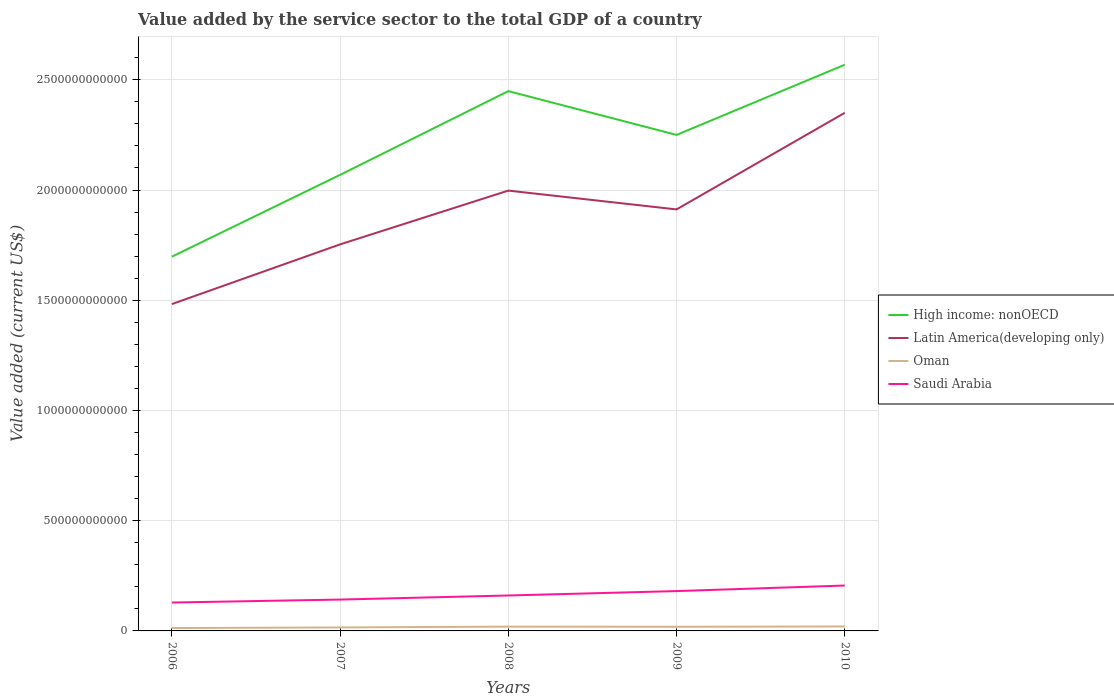How many different coloured lines are there?
Give a very brief answer. 4. Is the number of lines equal to the number of legend labels?
Ensure brevity in your answer.  Yes. Across all years, what is the maximum value added by the service sector to the total GDP in Saudi Arabia?
Offer a terse response. 1.29e+11. What is the total value added by the service sector to the total GDP in Oman in the graph?
Offer a very short reply. -2.80e+09. What is the difference between the highest and the second highest value added by the service sector to the total GDP in Latin America(developing only)?
Give a very brief answer. 8.68e+11. How many years are there in the graph?
Keep it short and to the point. 5. What is the difference between two consecutive major ticks on the Y-axis?
Keep it short and to the point. 5.00e+11. Does the graph contain any zero values?
Your response must be concise. No. Where does the legend appear in the graph?
Offer a very short reply. Center right. How many legend labels are there?
Provide a short and direct response. 4. How are the legend labels stacked?
Offer a very short reply. Vertical. What is the title of the graph?
Keep it short and to the point. Value added by the service sector to the total GDP of a country. Does "Russian Federation" appear as one of the legend labels in the graph?
Your response must be concise. No. What is the label or title of the Y-axis?
Offer a very short reply. Value added (current US$). What is the Value added (current US$) in High income: nonOECD in 2006?
Provide a short and direct response. 1.70e+12. What is the Value added (current US$) of Latin America(developing only) in 2006?
Offer a very short reply. 1.48e+12. What is the Value added (current US$) in Oman in 2006?
Your answer should be very brief. 1.30e+1. What is the Value added (current US$) in Saudi Arabia in 2006?
Ensure brevity in your answer.  1.29e+11. What is the Value added (current US$) in High income: nonOECD in 2007?
Make the answer very short. 2.07e+12. What is the Value added (current US$) of Latin America(developing only) in 2007?
Make the answer very short. 1.75e+12. What is the Value added (current US$) of Oman in 2007?
Keep it short and to the point. 1.58e+1. What is the Value added (current US$) of Saudi Arabia in 2007?
Your answer should be very brief. 1.42e+11. What is the Value added (current US$) in High income: nonOECD in 2008?
Your response must be concise. 2.45e+12. What is the Value added (current US$) of Latin America(developing only) in 2008?
Your answer should be compact. 2.00e+12. What is the Value added (current US$) in Oman in 2008?
Your answer should be very brief. 1.95e+1. What is the Value added (current US$) in Saudi Arabia in 2008?
Offer a terse response. 1.61e+11. What is the Value added (current US$) of High income: nonOECD in 2009?
Offer a very short reply. 2.25e+12. What is the Value added (current US$) in Latin America(developing only) in 2009?
Offer a very short reply. 1.91e+12. What is the Value added (current US$) in Oman in 2009?
Ensure brevity in your answer.  1.88e+1. What is the Value added (current US$) of Saudi Arabia in 2009?
Provide a succinct answer. 1.81e+11. What is the Value added (current US$) of High income: nonOECD in 2010?
Provide a short and direct response. 2.57e+12. What is the Value added (current US$) in Latin America(developing only) in 2010?
Provide a succinct answer. 2.35e+12. What is the Value added (current US$) of Oman in 2010?
Provide a succinct answer. 2.02e+1. What is the Value added (current US$) in Saudi Arabia in 2010?
Keep it short and to the point. 2.06e+11. Across all years, what is the maximum Value added (current US$) of High income: nonOECD?
Your answer should be compact. 2.57e+12. Across all years, what is the maximum Value added (current US$) of Latin America(developing only)?
Offer a very short reply. 2.35e+12. Across all years, what is the maximum Value added (current US$) in Oman?
Keep it short and to the point. 2.02e+1. Across all years, what is the maximum Value added (current US$) of Saudi Arabia?
Make the answer very short. 2.06e+11. Across all years, what is the minimum Value added (current US$) of High income: nonOECD?
Provide a short and direct response. 1.70e+12. Across all years, what is the minimum Value added (current US$) in Latin America(developing only)?
Provide a short and direct response. 1.48e+12. Across all years, what is the minimum Value added (current US$) of Oman?
Offer a terse response. 1.30e+1. Across all years, what is the minimum Value added (current US$) of Saudi Arabia?
Ensure brevity in your answer.  1.29e+11. What is the total Value added (current US$) in High income: nonOECD in the graph?
Provide a short and direct response. 1.10e+13. What is the total Value added (current US$) of Latin America(developing only) in the graph?
Your answer should be compact. 9.50e+12. What is the total Value added (current US$) in Oman in the graph?
Provide a short and direct response. 8.73e+1. What is the total Value added (current US$) of Saudi Arabia in the graph?
Give a very brief answer. 8.18e+11. What is the difference between the Value added (current US$) in High income: nonOECD in 2006 and that in 2007?
Provide a succinct answer. -3.71e+11. What is the difference between the Value added (current US$) of Latin America(developing only) in 2006 and that in 2007?
Keep it short and to the point. -2.71e+11. What is the difference between the Value added (current US$) in Oman in 2006 and that in 2007?
Your response must be concise. -2.80e+09. What is the difference between the Value added (current US$) of Saudi Arabia in 2006 and that in 2007?
Offer a terse response. -1.34e+1. What is the difference between the Value added (current US$) in High income: nonOECD in 2006 and that in 2008?
Your answer should be compact. -7.51e+11. What is the difference between the Value added (current US$) in Latin America(developing only) in 2006 and that in 2008?
Make the answer very short. -5.15e+11. What is the difference between the Value added (current US$) of Oman in 2006 and that in 2008?
Offer a very short reply. -6.47e+09. What is the difference between the Value added (current US$) in Saudi Arabia in 2006 and that in 2008?
Your answer should be very brief. -3.20e+1. What is the difference between the Value added (current US$) of High income: nonOECD in 2006 and that in 2009?
Make the answer very short. -5.52e+11. What is the difference between the Value added (current US$) in Latin America(developing only) in 2006 and that in 2009?
Provide a short and direct response. -4.29e+11. What is the difference between the Value added (current US$) in Oman in 2006 and that in 2009?
Your response must be concise. -5.85e+09. What is the difference between the Value added (current US$) of Saudi Arabia in 2006 and that in 2009?
Your answer should be very brief. -5.20e+1. What is the difference between the Value added (current US$) in High income: nonOECD in 2006 and that in 2010?
Keep it short and to the point. -8.71e+11. What is the difference between the Value added (current US$) in Latin America(developing only) in 2006 and that in 2010?
Offer a terse response. -8.68e+11. What is the difference between the Value added (current US$) in Oman in 2006 and that in 2010?
Your answer should be compact. -7.26e+09. What is the difference between the Value added (current US$) of Saudi Arabia in 2006 and that in 2010?
Give a very brief answer. -7.71e+1. What is the difference between the Value added (current US$) of High income: nonOECD in 2007 and that in 2008?
Offer a very short reply. -3.80e+11. What is the difference between the Value added (current US$) in Latin America(developing only) in 2007 and that in 2008?
Provide a succinct answer. -2.44e+11. What is the difference between the Value added (current US$) of Oman in 2007 and that in 2008?
Keep it short and to the point. -3.67e+09. What is the difference between the Value added (current US$) in Saudi Arabia in 2007 and that in 2008?
Make the answer very short. -1.85e+1. What is the difference between the Value added (current US$) in High income: nonOECD in 2007 and that in 2009?
Offer a very short reply. -1.81e+11. What is the difference between the Value added (current US$) of Latin America(developing only) in 2007 and that in 2009?
Provide a succinct answer. -1.59e+11. What is the difference between the Value added (current US$) of Oman in 2007 and that in 2009?
Your answer should be very brief. -3.05e+09. What is the difference between the Value added (current US$) of Saudi Arabia in 2007 and that in 2009?
Your response must be concise. -3.85e+1. What is the difference between the Value added (current US$) of High income: nonOECD in 2007 and that in 2010?
Keep it short and to the point. -4.99e+11. What is the difference between the Value added (current US$) of Latin America(developing only) in 2007 and that in 2010?
Give a very brief answer. -5.97e+11. What is the difference between the Value added (current US$) of Oman in 2007 and that in 2010?
Offer a terse response. -4.47e+09. What is the difference between the Value added (current US$) in Saudi Arabia in 2007 and that in 2010?
Your answer should be compact. -6.36e+1. What is the difference between the Value added (current US$) in High income: nonOECD in 2008 and that in 2009?
Offer a terse response. 1.99e+11. What is the difference between the Value added (current US$) of Latin America(developing only) in 2008 and that in 2009?
Offer a terse response. 8.53e+1. What is the difference between the Value added (current US$) of Oman in 2008 and that in 2009?
Keep it short and to the point. 6.25e+08. What is the difference between the Value added (current US$) of Saudi Arabia in 2008 and that in 2009?
Your answer should be very brief. -2.00e+1. What is the difference between the Value added (current US$) of High income: nonOECD in 2008 and that in 2010?
Ensure brevity in your answer.  -1.20e+11. What is the difference between the Value added (current US$) in Latin America(developing only) in 2008 and that in 2010?
Provide a short and direct response. -3.53e+11. What is the difference between the Value added (current US$) in Oman in 2008 and that in 2010?
Offer a very short reply. -7.91e+08. What is the difference between the Value added (current US$) of Saudi Arabia in 2008 and that in 2010?
Make the answer very short. -4.51e+1. What is the difference between the Value added (current US$) in High income: nonOECD in 2009 and that in 2010?
Give a very brief answer. -3.18e+11. What is the difference between the Value added (current US$) in Latin America(developing only) in 2009 and that in 2010?
Keep it short and to the point. -4.38e+11. What is the difference between the Value added (current US$) of Oman in 2009 and that in 2010?
Provide a short and direct response. -1.42e+09. What is the difference between the Value added (current US$) of Saudi Arabia in 2009 and that in 2010?
Make the answer very short. -2.51e+1. What is the difference between the Value added (current US$) of High income: nonOECD in 2006 and the Value added (current US$) of Latin America(developing only) in 2007?
Your response must be concise. -5.58e+1. What is the difference between the Value added (current US$) in High income: nonOECD in 2006 and the Value added (current US$) in Oman in 2007?
Give a very brief answer. 1.68e+12. What is the difference between the Value added (current US$) of High income: nonOECD in 2006 and the Value added (current US$) of Saudi Arabia in 2007?
Your response must be concise. 1.56e+12. What is the difference between the Value added (current US$) in Latin America(developing only) in 2006 and the Value added (current US$) in Oman in 2007?
Your answer should be very brief. 1.47e+12. What is the difference between the Value added (current US$) of Latin America(developing only) in 2006 and the Value added (current US$) of Saudi Arabia in 2007?
Keep it short and to the point. 1.34e+12. What is the difference between the Value added (current US$) of Oman in 2006 and the Value added (current US$) of Saudi Arabia in 2007?
Make the answer very short. -1.29e+11. What is the difference between the Value added (current US$) in High income: nonOECD in 2006 and the Value added (current US$) in Latin America(developing only) in 2008?
Make the answer very short. -3.00e+11. What is the difference between the Value added (current US$) of High income: nonOECD in 2006 and the Value added (current US$) of Oman in 2008?
Provide a succinct answer. 1.68e+12. What is the difference between the Value added (current US$) of High income: nonOECD in 2006 and the Value added (current US$) of Saudi Arabia in 2008?
Ensure brevity in your answer.  1.54e+12. What is the difference between the Value added (current US$) of Latin America(developing only) in 2006 and the Value added (current US$) of Oman in 2008?
Offer a terse response. 1.46e+12. What is the difference between the Value added (current US$) of Latin America(developing only) in 2006 and the Value added (current US$) of Saudi Arabia in 2008?
Your answer should be compact. 1.32e+12. What is the difference between the Value added (current US$) of Oman in 2006 and the Value added (current US$) of Saudi Arabia in 2008?
Your answer should be very brief. -1.48e+11. What is the difference between the Value added (current US$) of High income: nonOECD in 2006 and the Value added (current US$) of Latin America(developing only) in 2009?
Provide a succinct answer. -2.14e+11. What is the difference between the Value added (current US$) in High income: nonOECD in 2006 and the Value added (current US$) in Oman in 2009?
Offer a terse response. 1.68e+12. What is the difference between the Value added (current US$) of High income: nonOECD in 2006 and the Value added (current US$) of Saudi Arabia in 2009?
Keep it short and to the point. 1.52e+12. What is the difference between the Value added (current US$) in Latin America(developing only) in 2006 and the Value added (current US$) in Oman in 2009?
Offer a very short reply. 1.46e+12. What is the difference between the Value added (current US$) in Latin America(developing only) in 2006 and the Value added (current US$) in Saudi Arabia in 2009?
Your answer should be compact. 1.30e+12. What is the difference between the Value added (current US$) in Oman in 2006 and the Value added (current US$) in Saudi Arabia in 2009?
Your answer should be compact. -1.68e+11. What is the difference between the Value added (current US$) of High income: nonOECD in 2006 and the Value added (current US$) of Latin America(developing only) in 2010?
Provide a succinct answer. -6.53e+11. What is the difference between the Value added (current US$) of High income: nonOECD in 2006 and the Value added (current US$) of Oman in 2010?
Give a very brief answer. 1.68e+12. What is the difference between the Value added (current US$) of High income: nonOECD in 2006 and the Value added (current US$) of Saudi Arabia in 2010?
Provide a succinct answer. 1.49e+12. What is the difference between the Value added (current US$) of Latin America(developing only) in 2006 and the Value added (current US$) of Oman in 2010?
Keep it short and to the point. 1.46e+12. What is the difference between the Value added (current US$) in Latin America(developing only) in 2006 and the Value added (current US$) in Saudi Arabia in 2010?
Offer a very short reply. 1.28e+12. What is the difference between the Value added (current US$) of Oman in 2006 and the Value added (current US$) of Saudi Arabia in 2010?
Give a very brief answer. -1.93e+11. What is the difference between the Value added (current US$) of High income: nonOECD in 2007 and the Value added (current US$) of Latin America(developing only) in 2008?
Keep it short and to the point. 7.14e+1. What is the difference between the Value added (current US$) of High income: nonOECD in 2007 and the Value added (current US$) of Oman in 2008?
Keep it short and to the point. 2.05e+12. What is the difference between the Value added (current US$) in High income: nonOECD in 2007 and the Value added (current US$) in Saudi Arabia in 2008?
Provide a succinct answer. 1.91e+12. What is the difference between the Value added (current US$) of Latin America(developing only) in 2007 and the Value added (current US$) of Oman in 2008?
Your answer should be very brief. 1.73e+12. What is the difference between the Value added (current US$) in Latin America(developing only) in 2007 and the Value added (current US$) in Saudi Arabia in 2008?
Offer a very short reply. 1.59e+12. What is the difference between the Value added (current US$) in Oman in 2007 and the Value added (current US$) in Saudi Arabia in 2008?
Ensure brevity in your answer.  -1.45e+11. What is the difference between the Value added (current US$) in High income: nonOECD in 2007 and the Value added (current US$) in Latin America(developing only) in 2009?
Give a very brief answer. 1.57e+11. What is the difference between the Value added (current US$) in High income: nonOECD in 2007 and the Value added (current US$) in Oman in 2009?
Offer a very short reply. 2.05e+12. What is the difference between the Value added (current US$) in High income: nonOECD in 2007 and the Value added (current US$) in Saudi Arabia in 2009?
Give a very brief answer. 1.89e+12. What is the difference between the Value added (current US$) in Latin America(developing only) in 2007 and the Value added (current US$) in Oman in 2009?
Give a very brief answer. 1.73e+12. What is the difference between the Value added (current US$) in Latin America(developing only) in 2007 and the Value added (current US$) in Saudi Arabia in 2009?
Your answer should be compact. 1.57e+12. What is the difference between the Value added (current US$) in Oman in 2007 and the Value added (current US$) in Saudi Arabia in 2009?
Your response must be concise. -1.65e+11. What is the difference between the Value added (current US$) in High income: nonOECD in 2007 and the Value added (current US$) in Latin America(developing only) in 2010?
Provide a succinct answer. -2.81e+11. What is the difference between the Value added (current US$) in High income: nonOECD in 2007 and the Value added (current US$) in Oman in 2010?
Ensure brevity in your answer.  2.05e+12. What is the difference between the Value added (current US$) in High income: nonOECD in 2007 and the Value added (current US$) in Saudi Arabia in 2010?
Make the answer very short. 1.86e+12. What is the difference between the Value added (current US$) of Latin America(developing only) in 2007 and the Value added (current US$) of Oman in 2010?
Give a very brief answer. 1.73e+12. What is the difference between the Value added (current US$) of Latin America(developing only) in 2007 and the Value added (current US$) of Saudi Arabia in 2010?
Your answer should be very brief. 1.55e+12. What is the difference between the Value added (current US$) in Oman in 2007 and the Value added (current US$) in Saudi Arabia in 2010?
Offer a very short reply. -1.90e+11. What is the difference between the Value added (current US$) in High income: nonOECD in 2008 and the Value added (current US$) in Latin America(developing only) in 2009?
Keep it short and to the point. 5.37e+11. What is the difference between the Value added (current US$) of High income: nonOECD in 2008 and the Value added (current US$) of Oman in 2009?
Provide a succinct answer. 2.43e+12. What is the difference between the Value added (current US$) of High income: nonOECD in 2008 and the Value added (current US$) of Saudi Arabia in 2009?
Provide a succinct answer. 2.27e+12. What is the difference between the Value added (current US$) of Latin America(developing only) in 2008 and the Value added (current US$) of Oman in 2009?
Ensure brevity in your answer.  1.98e+12. What is the difference between the Value added (current US$) of Latin America(developing only) in 2008 and the Value added (current US$) of Saudi Arabia in 2009?
Keep it short and to the point. 1.82e+12. What is the difference between the Value added (current US$) of Oman in 2008 and the Value added (current US$) of Saudi Arabia in 2009?
Make the answer very short. -1.61e+11. What is the difference between the Value added (current US$) in High income: nonOECD in 2008 and the Value added (current US$) in Latin America(developing only) in 2010?
Give a very brief answer. 9.83e+1. What is the difference between the Value added (current US$) of High income: nonOECD in 2008 and the Value added (current US$) of Oman in 2010?
Provide a succinct answer. 2.43e+12. What is the difference between the Value added (current US$) of High income: nonOECD in 2008 and the Value added (current US$) of Saudi Arabia in 2010?
Provide a short and direct response. 2.24e+12. What is the difference between the Value added (current US$) of Latin America(developing only) in 2008 and the Value added (current US$) of Oman in 2010?
Give a very brief answer. 1.98e+12. What is the difference between the Value added (current US$) in Latin America(developing only) in 2008 and the Value added (current US$) in Saudi Arabia in 2010?
Ensure brevity in your answer.  1.79e+12. What is the difference between the Value added (current US$) in Oman in 2008 and the Value added (current US$) in Saudi Arabia in 2010?
Offer a terse response. -1.86e+11. What is the difference between the Value added (current US$) in High income: nonOECD in 2009 and the Value added (current US$) in Latin America(developing only) in 2010?
Ensure brevity in your answer.  -1.00e+11. What is the difference between the Value added (current US$) of High income: nonOECD in 2009 and the Value added (current US$) of Oman in 2010?
Provide a short and direct response. 2.23e+12. What is the difference between the Value added (current US$) of High income: nonOECD in 2009 and the Value added (current US$) of Saudi Arabia in 2010?
Provide a succinct answer. 2.04e+12. What is the difference between the Value added (current US$) in Latin America(developing only) in 2009 and the Value added (current US$) in Oman in 2010?
Offer a terse response. 1.89e+12. What is the difference between the Value added (current US$) of Latin America(developing only) in 2009 and the Value added (current US$) of Saudi Arabia in 2010?
Your answer should be very brief. 1.71e+12. What is the difference between the Value added (current US$) in Oman in 2009 and the Value added (current US$) in Saudi Arabia in 2010?
Make the answer very short. -1.87e+11. What is the average Value added (current US$) in High income: nonOECD per year?
Make the answer very short. 2.21e+12. What is the average Value added (current US$) in Latin America(developing only) per year?
Ensure brevity in your answer.  1.90e+12. What is the average Value added (current US$) of Oman per year?
Your answer should be compact. 1.75e+1. What is the average Value added (current US$) of Saudi Arabia per year?
Give a very brief answer. 1.64e+11. In the year 2006, what is the difference between the Value added (current US$) in High income: nonOECD and Value added (current US$) in Latin America(developing only)?
Keep it short and to the point. 2.15e+11. In the year 2006, what is the difference between the Value added (current US$) in High income: nonOECD and Value added (current US$) in Oman?
Offer a terse response. 1.68e+12. In the year 2006, what is the difference between the Value added (current US$) in High income: nonOECD and Value added (current US$) in Saudi Arabia?
Make the answer very short. 1.57e+12. In the year 2006, what is the difference between the Value added (current US$) in Latin America(developing only) and Value added (current US$) in Oman?
Keep it short and to the point. 1.47e+12. In the year 2006, what is the difference between the Value added (current US$) in Latin America(developing only) and Value added (current US$) in Saudi Arabia?
Offer a very short reply. 1.35e+12. In the year 2006, what is the difference between the Value added (current US$) of Oman and Value added (current US$) of Saudi Arabia?
Provide a succinct answer. -1.16e+11. In the year 2007, what is the difference between the Value added (current US$) in High income: nonOECD and Value added (current US$) in Latin America(developing only)?
Your answer should be compact. 3.15e+11. In the year 2007, what is the difference between the Value added (current US$) in High income: nonOECD and Value added (current US$) in Oman?
Make the answer very short. 2.05e+12. In the year 2007, what is the difference between the Value added (current US$) of High income: nonOECD and Value added (current US$) of Saudi Arabia?
Give a very brief answer. 1.93e+12. In the year 2007, what is the difference between the Value added (current US$) in Latin America(developing only) and Value added (current US$) in Oman?
Your response must be concise. 1.74e+12. In the year 2007, what is the difference between the Value added (current US$) in Latin America(developing only) and Value added (current US$) in Saudi Arabia?
Offer a very short reply. 1.61e+12. In the year 2007, what is the difference between the Value added (current US$) of Oman and Value added (current US$) of Saudi Arabia?
Provide a short and direct response. -1.26e+11. In the year 2008, what is the difference between the Value added (current US$) of High income: nonOECD and Value added (current US$) of Latin America(developing only)?
Give a very brief answer. 4.51e+11. In the year 2008, what is the difference between the Value added (current US$) in High income: nonOECD and Value added (current US$) in Oman?
Your answer should be compact. 2.43e+12. In the year 2008, what is the difference between the Value added (current US$) of High income: nonOECD and Value added (current US$) of Saudi Arabia?
Your answer should be compact. 2.29e+12. In the year 2008, what is the difference between the Value added (current US$) in Latin America(developing only) and Value added (current US$) in Oman?
Offer a very short reply. 1.98e+12. In the year 2008, what is the difference between the Value added (current US$) in Latin America(developing only) and Value added (current US$) in Saudi Arabia?
Offer a terse response. 1.84e+12. In the year 2008, what is the difference between the Value added (current US$) in Oman and Value added (current US$) in Saudi Arabia?
Make the answer very short. -1.41e+11. In the year 2009, what is the difference between the Value added (current US$) in High income: nonOECD and Value added (current US$) in Latin America(developing only)?
Offer a very short reply. 3.38e+11. In the year 2009, what is the difference between the Value added (current US$) in High income: nonOECD and Value added (current US$) in Oman?
Your answer should be compact. 2.23e+12. In the year 2009, what is the difference between the Value added (current US$) in High income: nonOECD and Value added (current US$) in Saudi Arabia?
Provide a short and direct response. 2.07e+12. In the year 2009, what is the difference between the Value added (current US$) of Latin America(developing only) and Value added (current US$) of Oman?
Your response must be concise. 1.89e+12. In the year 2009, what is the difference between the Value added (current US$) in Latin America(developing only) and Value added (current US$) in Saudi Arabia?
Provide a short and direct response. 1.73e+12. In the year 2009, what is the difference between the Value added (current US$) in Oman and Value added (current US$) in Saudi Arabia?
Make the answer very short. -1.62e+11. In the year 2010, what is the difference between the Value added (current US$) of High income: nonOECD and Value added (current US$) of Latin America(developing only)?
Your response must be concise. 2.18e+11. In the year 2010, what is the difference between the Value added (current US$) in High income: nonOECD and Value added (current US$) in Oman?
Keep it short and to the point. 2.55e+12. In the year 2010, what is the difference between the Value added (current US$) of High income: nonOECD and Value added (current US$) of Saudi Arabia?
Keep it short and to the point. 2.36e+12. In the year 2010, what is the difference between the Value added (current US$) of Latin America(developing only) and Value added (current US$) of Oman?
Offer a very short reply. 2.33e+12. In the year 2010, what is the difference between the Value added (current US$) in Latin America(developing only) and Value added (current US$) in Saudi Arabia?
Give a very brief answer. 2.14e+12. In the year 2010, what is the difference between the Value added (current US$) in Oman and Value added (current US$) in Saudi Arabia?
Ensure brevity in your answer.  -1.86e+11. What is the ratio of the Value added (current US$) of High income: nonOECD in 2006 to that in 2007?
Offer a terse response. 0.82. What is the ratio of the Value added (current US$) in Latin America(developing only) in 2006 to that in 2007?
Make the answer very short. 0.85. What is the ratio of the Value added (current US$) of Oman in 2006 to that in 2007?
Your answer should be very brief. 0.82. What is the ratio of the Value added (current US$) in Saudi Arabia in 2006 to that in 2007?
Offer a very short reply. 0.91. What is the ratio of the Value added (current US$) of High income: nonOECD in 2006 to that in 2008?
Ensure brevity in your answer.  0.69. What is the ratio of the Value added (current US$) of Latin America(developing only) in 2006 to that in 2008?
Your response must be concise. 0.74. What is the ratio of the Value added (current US$) in Oman in 2006 to that in 2008?
Your answer should be very brief. 0.67. What is the ratio of the Value added (current US$) in Saudi Arabia in 2006 to that in 2008?
Offer a very short reply. 0.8. What is the ratio of the Value added (current US$) of High income: nonOECD in 2006 to that in 2009?
Keep it short and to the point. 0.75. What is the ratio of the Value added (current US$) in Latin America(developing only) in 2006 to that in 2009?
Ensure brevity in your answer.  0.78. What is the ratio of the Value added (current US$) of Oman in 2006 to that in 2009?
Your answer should be compact. 0.69. What is the ratio of the Value added (current US$) of Saudi Arabia in 2006 to that in 2009?
Your answer should be very brief. 0.71. What is the ratio of the Value added (current US$) in High income: nonOECD in 2006 to that in 2010?
Provide a short and direct response. 0.66. What is the ratio of the Value added (current US$) in Latin America(developing only) in 2006 to that in 2010?
Offer a terse response. 0.63. What is the ratio of the Value added (current US$) of Oman in 2006 to that in 2010?
Provide a short and direct response. 0.64. What is the ratio of the Value added (current US$) in Saudi Arabia in 2006 to that in 2010?
Offer a very short reply. 0.63. What is the ratio of the Value added (current US$) of High income: nonOECD in 2007 to that in 2008?
Your answer should be compact. 0.84. What is the ratio of the Value added (current US$) in Latin America(developing only) in 2007 to that in 2008?
Your answer should be compact. 0.88. What is the ratio of the Value added (current US$) of Oman in 2007 to that in 2008?
Offer a terse response. 0.81. What is the ratio of the Value added (current US$) of Saudi Arabia in 2007 to that in 2008?
Offer a very short reply. 0.88. What is the ratio of the Value added (current US$) in High income: nonOECD in 2007 to that in 2009?
Give a very brief answer. 0.92. What is the ratio of the Value added (current US$) of Latin America(developing only) in 2007 to that in 2009?
Your answer should be very brief. 0.92. What is the ratio of the Value added (current US$) of Oman in 2007 to that in 2009?
Make the answer very short. 0.84. What is the ratio of the Value added (current US$) of Saudi Arabia in 2007 to that in 2009?
Provide a succinct answer. 0.79. What is the ratio of the Value added (current US$) in High income: nonOECD in 2007 to that in 2010?
Keep it short and to the point. 0.81. What is the ratio of the Value added (current US$) in Latin America(developing only) in 2007 to that in 2010?
Your answer should be very brief. 0.75. What is the ratio of the Value added (current US$) of Oman in 2007 to that in 2010?
Your answer should be compact. 0.78. What is the ratio of the Value added (current US$) of Saudi Arabia in 2007 to that in 2010?
Provide a succinct answer. 0.69. What is the ratio of the Value added (current US$) in High income: nonOECD in 2008 to that in 2009?
Provide a succinct answer. 1.09. What is the ratio of the Value added (current US$) of Latin America(developing only) in 2008 to that in 2009?
Provide a short and direct response. 1.04. What is the ratio of the Value added (current US$) in Oman in 2008 to that in 2009?
Your answer should be compact. 1.03. What is the ratio of the Value added (current US$) of Saudi Arabia in 2008 to that in 2009?
Your answer should be very brief. 0.89. What is the ratio of the Value added (current US$) of High income: nonOECD in 2008 to that in 2010?
Provide a short and direct response. 0.95. What is the ratio of the Value added (current US$) of Latin America(developing only) in 2008 to that in 2010?
Give a very brief answer. 0.85. What is the ratio of the Value added (current US$) in Oman in 2008 to that in 2010?
Ensure brevity in your answer.  0.96. What is the ratio of the Value added (current US$) of Saudi Arabia in 2008 to that in 2010?
Your answer should be very brief. 0.78. What is the ratio of the Value added (current US$) in High income: nonOECD in 2009 to that in 2010?
Keep it short and to the point. 0.88. What is the ratio of the Value added (current US$) in Latin America(developing only) in 2009 to that in 2010?
Give a very brief answer. 0.81. What is the ratio of the Value added (current US$) of Saudi Arabia in 2009 to that in 2010?
Make the answer very short. 0.88. What is the difference between the highest and the second highest Value added (current US$) of High income: nonOECD?
Provide a short and direct response. 1.20e+11. What is the difference between the highest and the second highest Value added (current US$) in Latin America(developing only)?
Offer a very short reply. 3.53e+11. What is the difference between the highest and the second highest Value added (current US$) of Oman?
Make the answer very short. 7.91e+08. What is the difference between the highest and the second highest Value added (current US$) in Saudi Arabia?
Offer a terse response. 2.51e+1. What is the difference between the highest and the lowest Value added (current US$) of High income: nonOECD?
Offer a terse response. 8.71e+11. What is the difference between the highest and the lowest Value added (current US$) in Latin America(developing only)?
Make the answer very short. 8.68e+11. What is the difference between the highest and the lowest Value added (current US$) of Oman?
Your answer should be compact. 7.26e+09. What is the difference between the highest and the lowest Value added (current US$) of Saudi Arabia?
Give a very brief answer. 7.71e+1. 